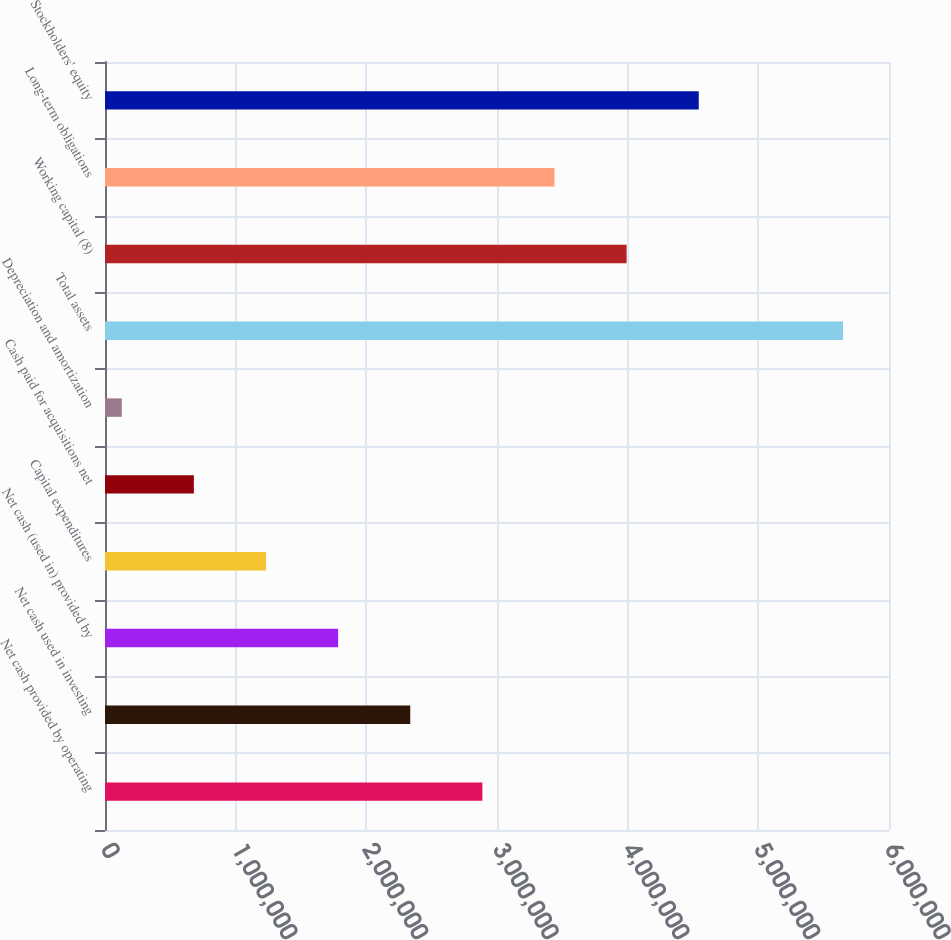Convert chart to OTSL. <chart><loc_0><loc_0><loc_500><loc_500><bar_chart><fcel>Net cash provided by operating<fcel>Net cash used in investing<fcel>Net cash (used in) provided by<fcel>Capital expenditures<fcel>Cash paid for acquisitions net<fcel>Depreciation and amortization<fcel>Total assets<fcel>Working capital (8)<fcel>Long-term obligations<fcel>Stockholders' equity<nl><fcel>2.88801e+06<fcel>2.33605e+06<fcel>1.78409e+06<fcel>1.23212e+06<fcel>680156<fcel>128192<fcel>5.64784e+06<fcel>3.99194e+06<fcel>3.43998e+06<fcel>4.54391e+06<nl></chart> 